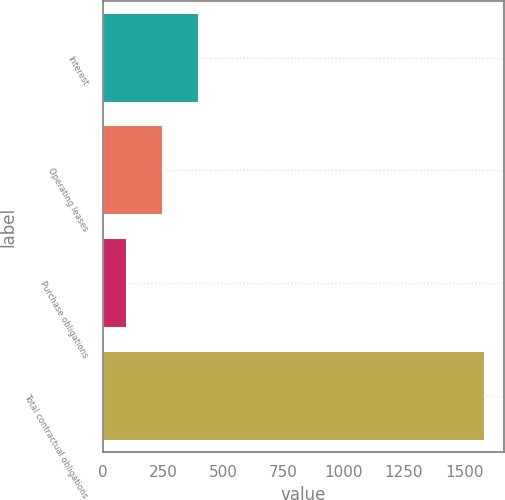<chart> <loc_0><loc_0><loc_500><loc_500><bar_chart><fcel>Interest<fcel>Operating leases<fcel>Purchase obligations<fcel>Total contractual obligations<nl><fcel>398.2<fcel>249.6<fcel>101<fcel>1587<nl></chart> 